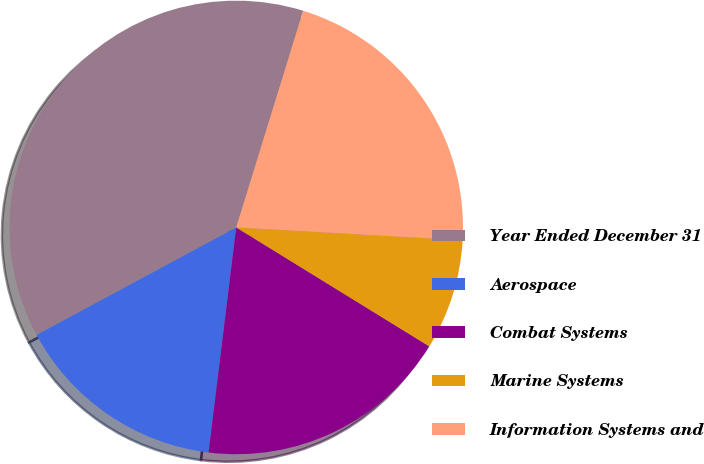Convert chart to OTSL. <chart><loc_0><loc_0><loc_500><loc_500><pie_chart><fcel>Year Ended December 31<fcel>Aerospace<fcel>Combat Systems<fcel>Marine Systems<fcel>Information Systems and<nl><fcel>37.63%<fcel>15.19%<fcel>18.16%<fcel>7.89%<fcel>21.13%<nl></chart> 